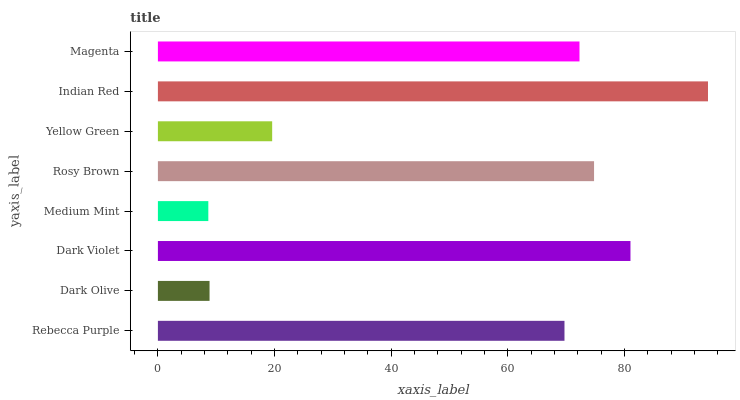Is Medium Mint the minimum?
Answer yes or no. Yes. Is Indian Red the maximum?
Answer yes or no. Yes. Is Dark Olive the minimum?
Answer yes or no. No. Is Dark Olive the maximum?
Answer yes or no. No. Is Rebecca Purple greater than Dark Olive?
Answer yes or no. Yes. Is Dark Olive less than Rebecca Purple?
Answer yes or no. Yes. Is Dark Olive greater than Rebecca Purple?
Answer yes or no. No. Is Rebecca Purple less than Dark Olive?
Answer yes or no. No. Is Magenta the high median?
Answer yes or no. Yes. Is Rebecca Purple the low median?
Answer yes or no. Yes. Is Medium Mint the high median?
Answer yes or no. No. Is Dark Violet the low median?
Answer yes or no. No. 